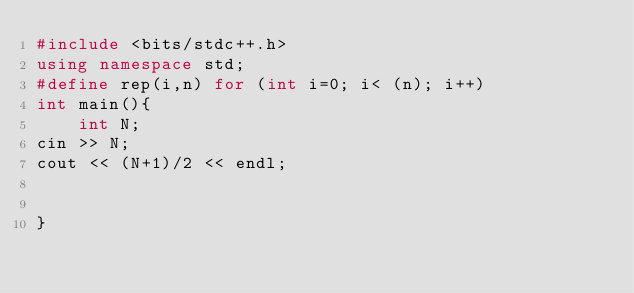Convert code to text. <code><loc_0><loc_0><loc_500><loc_500><_C++_>#include <bits/stdc++.h>
using namespace std;
#define rep(i,n) for (int i=0; i< (n); i++)
int main(){
    int N;
cin >> N;
cout << (N+1)/2 << endl; 


}</code> 